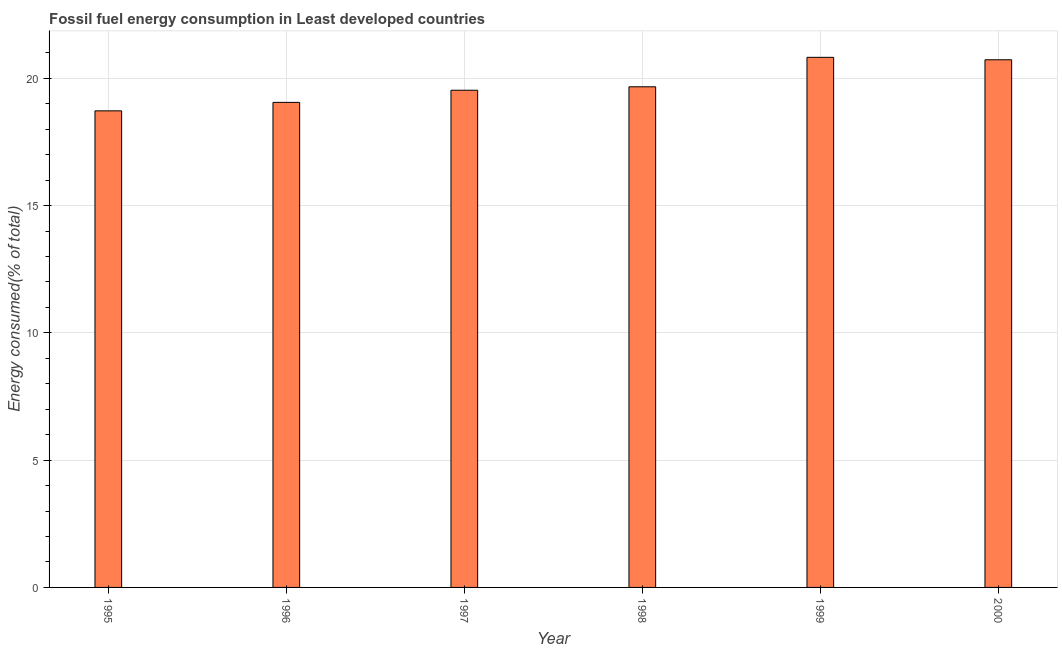Does the graph contain any zero values?
Your response must be concise. No. What is the title of the graph?
Provide a succinct answer. Fossil fuel energy consumption in Least developed countries. What is the label or title of the Y-axis?
Your answer should be very brief. Energy consumed(% of total). What is the fossil fuel energy consumption in 1996?
Provide a succinct answer. 19.05. Across all years, what is the maximum fossil fuel energy consumption?
Your answer should be compact. 20.82. Across all years, what is the minimum fossil fuel energy consumption?
Give a very brief answer. 18.72. In which year was the fossil fuel energy consumption minimum?
Give a very brief answer. 1995. What is the sum of the fossil fuel energy consumption?
Make the answer very short. 118.52. What is the difference between the fossil fuel energy consumption in 1998 and 1999?
Provide a succinct answer. -1.16. What is the average fossil fuel energy consumption per year?
Make the answer very short. 19.75. What is the median fossil fuel energy consumption?
Your response must be concise. 19.6. Do a majority of the years between 1999 and 1998 (inclusive) have fossil fuel energy consumption greater than 9 %?
Offer a very short reply. No. What is the ratio of the fossil fuel energy consumption in 1998 to that in 2000?
Offer a very short reply. 0.95. What is the difference between the highest and the second highest fossil fuel energy consumption?
Give a very brief answer. 0.1. Is the sum of the fossil fuel energy consumption in 1996 and 1999 greater than the maximum fossil fuel energy consumption across all years?
Ensure brevity in your answer.  Yes. How many bars are there?
Offer a terse response. 6. Are all the bars in the graph horizontal?
Keep it short and to the point. No. How many years are there in the graph?
Keep it short and to the point. 6. Are the values on the major ticks of Y-axis written in scientific E-notation?
Provide a short and direct response. No. What is the Energy consumed(% of total) of 1995?
Make the answer very short. 18.72. What is the Energy consumed(% of total) of 1996?
Your answer should be compact. 19.05. What is the Energy consumed(% of total) of 1997?
Keep it short and to the point. 19.53. What is the Energy consumed(% of total) in 1998?
Provide a short and direct response. 19.67. What is the Energy consumed(% of total) in 1999?
Your answer should be compact. 20.82. What is the Energy consumed(% of total) of 2000?
Your answer should be compact. 20.73. What is the difference between the Energy consumed(% of total) in 1995 and 1996?
Your answer should be compact. -0.33. What is the difference between the Energy consumed(% of total) in 1995 and 1997?
Provide a short and direct response. -0.81. What is the difference between the Energy consumed(% of total) in 1995 and 1998?
Your answer should be very brief. -0.95. What is the difference between the Energy consumed(% of total) in 1995 and 1999?
Offer a very short reply. -2.1. What is the difference between the Energy consumed(% of total) in 1995 and 2000?
Keep it short and to the point. -2.01. What is the difference between the Energy consumed(% of total) in 1996 and 1997?
Provide a succinct answer. -0.48. What is the difference between the Energy consumed(% of total) in 1996 and 1998?
Keep it short and to the point. -0.61. What is the difference between the Energy consumed(% of total) in 1996 and 1999?
Your response must be concise. -1.77. What is the difference between the Energy consumed(% of total) in 1996 and 2000?
Your answer should be compact. -1.67. What is the difference between the Energy consumed(% of total) in 1997 and 1998?
Provide a succinct answer. -0.14. What is the difference between the Energy consumed(% of total) in 1997 and 1999?
Your answer should be very brief. -1.29. What is the difference between the Energy consumed(% of total) in 1997 and 2000?
Keep it short and to the point. -1.2. What is the difference between the Energy consumed(% of total) in 1998 and 1999?
Keep it short and to the point. -1.16. What is the difference between the Energy consumed(% of total) in 1998 and 2000?
Offer a very short reply. -1.06. What is the difference between the Energy consumed(% of total) in 1999 and 2000?
Provide a succinct answer. 0.1. What is the ratio of the Energy consumed(% of total) in 1995 to that in 1999?
Ensure brevity in your answer.  0.9. What is the ratio of the Energy consumed(% of total) in 1995 to that in 2000?
Ensure brevity in your answer.  0.9. What is the ratio of the Energy consumed(% of total) in 1996 to that in 1998?
Your response must be concise. 0.97. What is the ratio of the Energy consumed(% of total) in 1996 to that in 1999?
Your answer should be very brief. 0.92. What is the ratio of the Energy consumed(% of total) in 1996 to that in 2000?
Keep it short and to the point. 0.92. What is the ratio of the Energy consumed(% of total) in 1997 to that in 1999?
Your answer should be very brief. 0.94. What is the ratio of the Energy consumed(% of total) in 1997 to that in 2000?
Keep it short and to the point. 0.94. What is the ratio of the Energy consumed(% of total) in 1998 to that in 1999?
Your response must be concise. 0.94. What is the ratio of the Energy consumed(% of total) in 1998 to that in 2000?
Your answer should be compact. 0.95. What is the ratio of the Energy consumed(% of total) in 1999 to that in 2000?
Give a very brief answer. 1. 